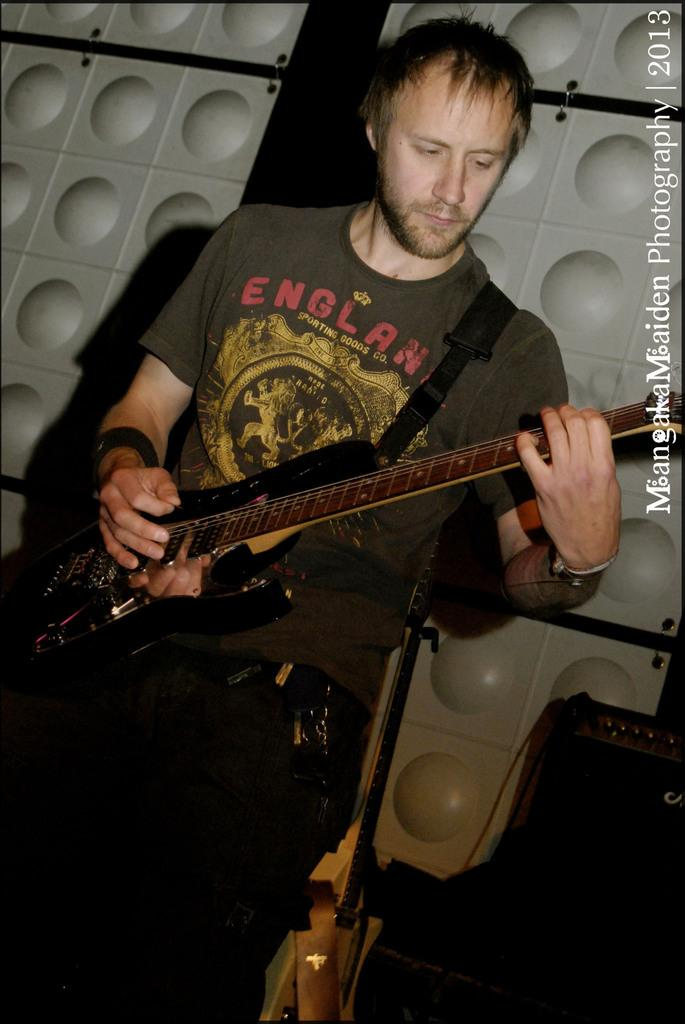What is the man in the image doing? The man is playing a guitar in the image. What can be seen in the background of the image? There is a wall in the background of the image. Is there any text visible in the image? Yes, there is text visible on the top right of the image. Is the man playing volleyball in the image? No, the man is playing a guitar, not volleyball. 